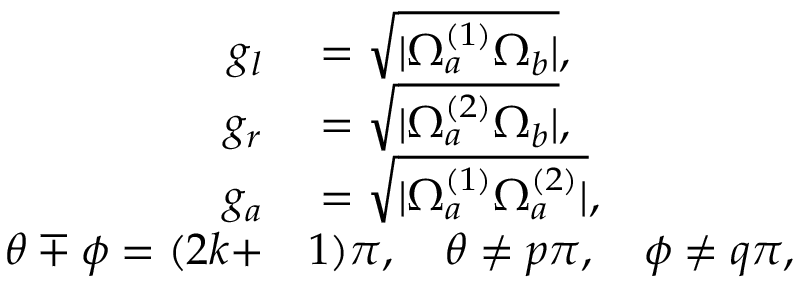<formula> <loc_0><loc_0><loc_500><loc_500>\begin{array} { r l } { g _ { l } } & = \sqrt { | \Omega _ { a } ^ { ( 1 ) } \Omega _ { b } | } , } \\ { g _ { r } } & = \sqrt { | \Omega _ { a } ^ { ( 2 ) } \Omega _ { b } | } , } \\ { g _ { a } } & = \sqrt { | \Omega _ { a } ^ { ( 1 ) } \Omega _ { a } ^ { ( 2 ) } | } , } \\ { \theta \mp \phi = ( 2 k + } & 1 ) \pi , \quad \theta \neq p \pi , \quad \phi \neq q \pi , } \end{array}</formula> 